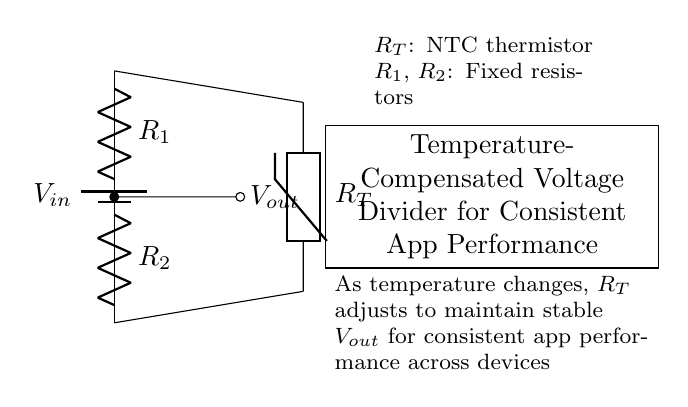What are the components in the circuit? The two fixed resistors and a thermistor are present, denoted as R1, R2, and RT respectively.
Answer: R1, R2, RT What does Vout indicate in this circuit? Vout represents the output voltage from the voltage divider, which is taken across R2 and adjusted by the thermistor's resistance.
Answer: Output voltage What is the purpose of the NTC thermistor in the circuit? The NTC thermistor changes resistance with temperature, which helps to stabilize the output voltage as temperature varies.
Answer: Temperature compensation How does the circuit maintain consistent performance across devices? Vout is kept stable due to the thermistor adjusting resistance, balancing R1 and R2 as temperature changes, ensuring consistent outputs.
Answer: Stable output voltage What happens to Vout if the temperature increases? As temperature increases, the resistance of the NTC thermistor decreases, decreasing the voltage drop across R2 and adjusting Vout accordingly.
Answer: Decreases What type of circuit is depicted? This is a voltage divider circuit, which distributes input voltage across the resistors and provides an adjustable output voltage based on resistance configuration.
Answer: Voltage divider 